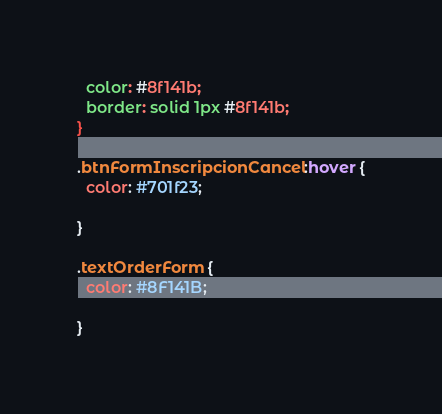<code> <loc_0><loc_0><loc_500><loc_500><_CSS_>  color: #8f141b;
  border: solid 1px #8f141b;
}

.btnFormInscripcionCancel:hover {
  color: #701f23;

}

.textOrderForm {
  color: #8F141B;

}</code> 